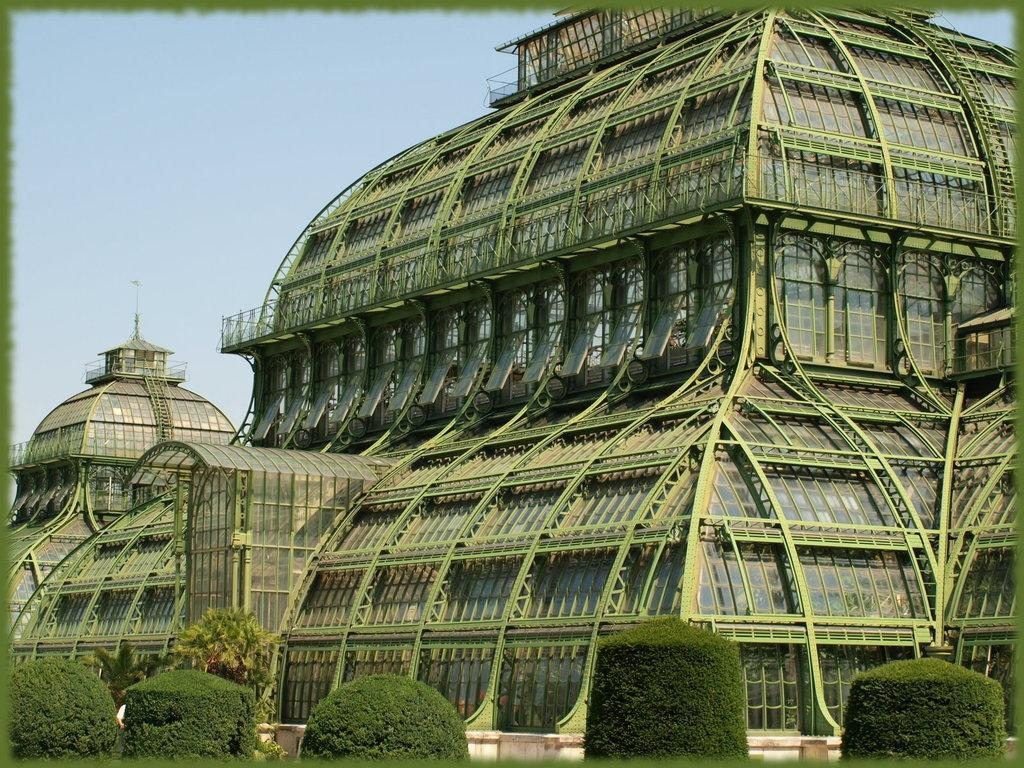What type of building is shown in the image? There is a green color iron frame building in the image. What can be seen at the bottom front of the building? There are plant bushes in the front bottom side of the image. What is the color of the sky visible in the background? There is a blue sky visible in the background of the image. What type of liquid is being poured by the crow in the image? There is no crow or liquid present in the image. 